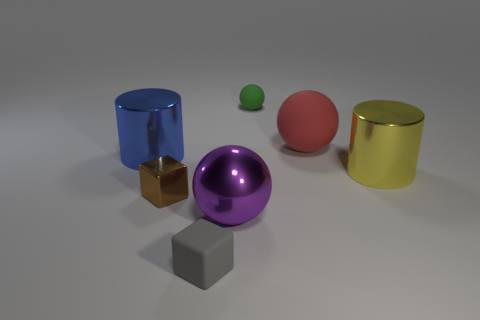There is a green matte thing; how many large red rubber spheres are left of it?
Offer a terse response. 0. Does the large cylinder left of the rubber cube have the same material as the tiny object that is on the right side of the small matte cube?
Offer a very short reply. No. What number of things are shiny objects in front of the brown cube or yellow metal cylinders?
Give a very brief answer. 2. Is the number of shiny things that are in front of the gray rubber thing less than the number of small objects that are in front of the yellow metal object?
Your answer should be compact. Yes. What number of other objects are the same size as the blue thing?
Make the answer very short. 3. Are the brown cube and the tiny object that is behind the big blue metallic cylinder made of the same material?
Provide a succinct answer. No. How many objects are either cylinders on the left side of the small gray matte thing or cylinders that are left of the large red ball?
Your answer should be very brief. 1. What is the color of the large rubber sphere?
Make the answer very short. Red. Are there fewer green rubber objects to the right of the big blue cylinder than big gray matte objects?
Give a very brief answer. No. Are any large yellow matte cubes visible?
Make the answer very short. No. 